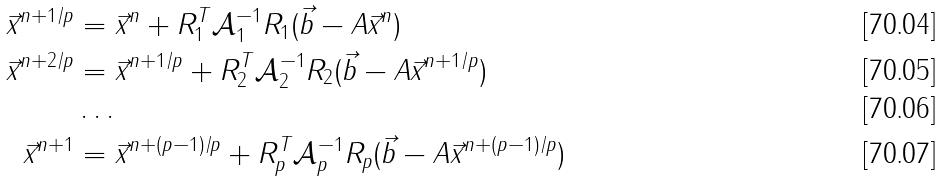Convert formula to latex. <formula><loc_0><loc_0><loc_500><loc_500>\vec { x } ^ { n + 1 / p } & = \vec { x } ^ { n } + R _ { 1 } ^ { T } \mathcal { A } _ { 1 } ^ { - 1 } R _ { 1 } ( \vec { b } - A \vec { x } ^ { n } ) \\ \vec { x } ^ { n + 2 / p } & = \vec { x } ^ { n + 1 / p } + R _ { 2 } ^ { T } \mathcal { A } _ { 2 } ^ { - 1 } R _ { 2 } ( \vec { b } - A \vec { x } ^ { n + 1 / p } ) \\ & \dots \\ \vec { x } ^ { n + 1 } & = \vec { x } ^ { n + ( p - 1 ) / p } + R _ { p } ^ { T } \mathcal { A } _ { p } ^ { - 1 } R _ { p } ( \vec { b } - A \vec { x } ^ { n + ( p - 1 ) / p } )</formula> 